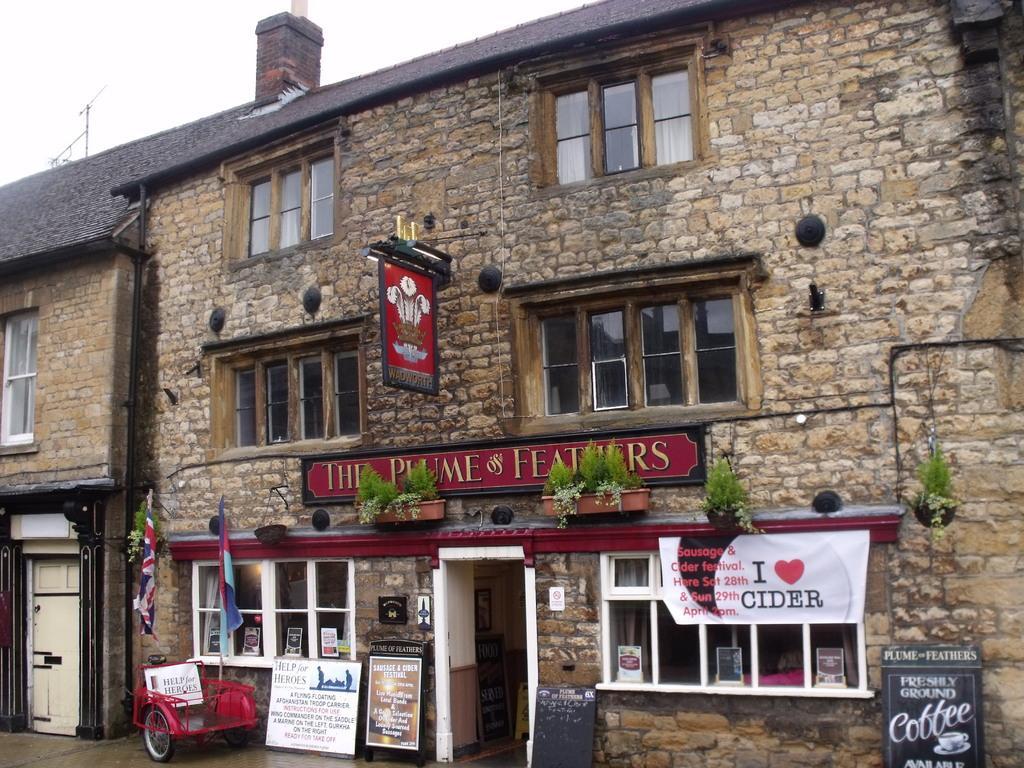Can you describe this image briefly? In this picture we can see a building with windows, houseplants, banners, flags and in the background we can see the sky with clouds. 